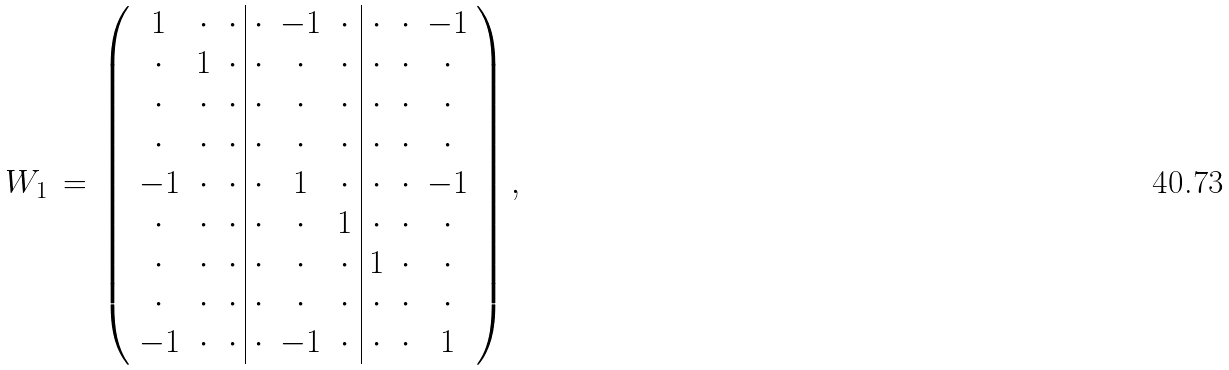<formula> <loc_0><loc_0><loc_500><loc_500>W _ { 1 } \, = \, \left ( \begin{array} { c c c | c c c | c c c } 1 & \cdot & \cdot & \cdot & - 1 & \cdot & \cdot & \cdot & - 1 \\ \cdot & 1 & \cdot & \cdot & \cdot & \cdot & \cdot & \cdot & \cdot \\ \cdot & \cdot & \cdot & \cdot & \cdot & \cdot & \cdot & \cdot & \cdot \\ \cdot & \cdot & \cdot & \cdot & \cdot & \cdot & \cdot & \cdot & \cdot \\ - 1 & \cdot & \cdot & \cdot & 1 & \cdot & \cdot & \cdot & - 1 \\ \cdot & \cdot & \cdot & \cdot & \cdot & 1 & \cdot & \cdot & \cdot \\ \cdot & \cdot & \cdot & \cdot & \cdot & \cdot & 1 & \cdot & \cdot \\ \cdot & \cdot & \cdot & \cdot & \cdot & \cdot & \cdot & \cdot & \cdot \\ - 1 & \cdot & \cdot & \cdot & - 1 & \cdot & \cdot & \cdot & 1 \end{array} \right ) ,</formula> 